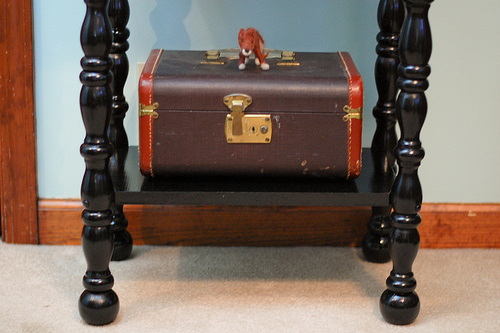<image>
Can you confirm if the suitcase is on the floor? No. The suitcase is not positioned on the floor. They may be near each other, but the suitcase is not supported by or resting on top of the floor. Is there a toy next to the box? No. The toy is not positioned next to the box. They are located in different areas of the scene. 